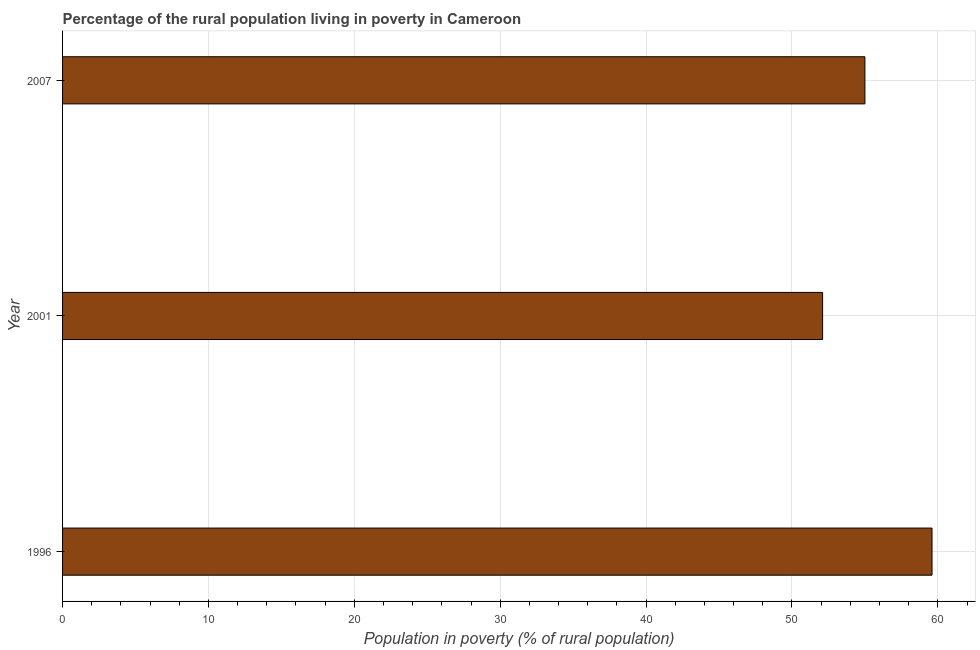Does the graph contain any zero values?
Keep it short and to the point. No. Does the graph contain grids?
Make the answer very short. Yes. What is the title of the graph?
Your answer should be very brief. Percentage of the rural population living in poverty in Cameroon. What is the label or title of the X-axis?
Your answer should be compact. Population in poverty (% of rural population). What is the label or title of the Y-axis?
Make the answer very short. Year. What is the percentage of rural population living below poverty line in 2001?
Make the answer very short. 52.1. Across all years, what is the maximum percentage of rural population living below poverty line?
Keep it short and to the point. 59.6. Across all years, what is the minimum percentage of rural population living below poverty line?
Give a very brief answer. 52.1. What is the sum of the percentage of rural population living below poverty line?
Give a very brief answer. 166.7. What is the difference between the percentage of rural population living below poverty line in 1996 and 2007?
Your answer should be compact. 4.6. What is the average percentage of rural population living below poverty line per year?
Ensure brevity in your answer.  55.57. Do a majority of the years between 2007 and 1996 (inclusive) have percentage of rural population living below poverty line greater than 38 %?
Give a very brief answer. Yes. What is the ratio of the percentage of rural population living below poverty line in 1996 to that in 2001?
Provide a short and direct response. 1.14. Is the sum of the percentage of rural population living below poverty line in 1996 and 2001 greater than the maximum percentage of rural population living below poverty line across all years?
Make the answer very short. Yes. What is the difference between two consecutive major ticks on the X-axis?
Your response must be concise. 10. Are the values on the major ticks of X-axis written in scientific E-notation?
Your answer should be compact. No. What is the Population in poverty (% of rural population) of 1996?
Ensure brevity in your answer.  59.6. What is the Population in poverty (% of rural population) of 2001?
Your answer should be very brief. 52.1. What is the Population in poverty (% of rural population) in 2007?
Your answer should be very brief. 55. What is the difference between the Population in poverty (% of rural population) in 1996 and 2001?
Make the answer very short. 7.5. What is the difference between the Population in poverty (% of rural population) in 1996 and 2007?
Keep it short and to the point. 4.6. What is the ratio of the Population in poverty (% of rural population) in 1996 to that in 2001?
Provide a succinct answer. 1.14. What is the ratio of the Population in poverty (% of rural population) in 1996 to that in 2007?
Your answer should be compact. 1.08. What is the ratio of the Population in poverty (% of rural population) in 2001 to that in 2007?
Offer a very short reply. 0.95. 